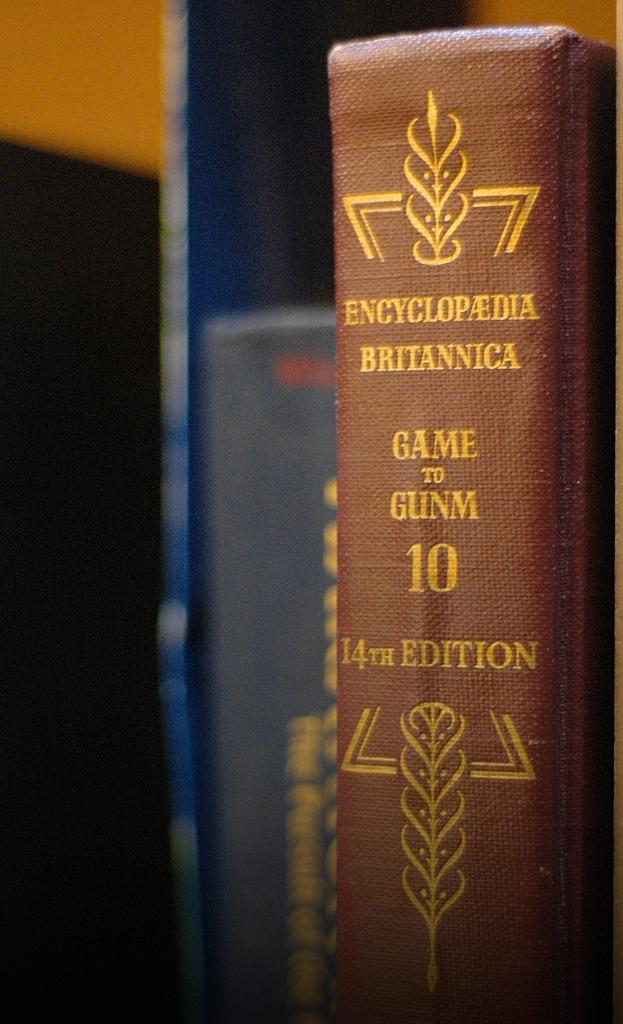<image>
Summarize the visual content of the image. A brown Encylcopedia Britannica with gold lettering sitting upright. 